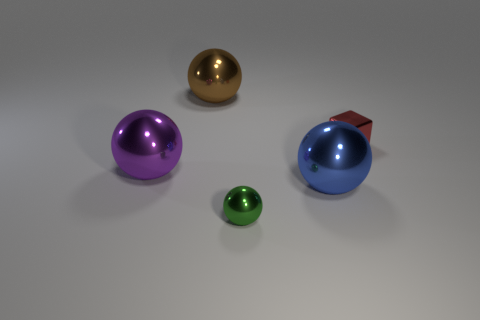Is the number of large purple balls that are right of the big purple object less than the number of green blocks?
Provide a short and direct response. No. Are there any red things that have the same material as the big purple ball?
Your answer should be compact. Yes. There is a red object; is its size the same as the brown object behind the large blue object?
Your response must be concise. No. Is there a metal sphere that has the same color as the tiny block?
Ensure brevity in your answer.  No. There is a big purple metallic object; how many objects are in front of it?
Give a very brief answer. 2. What is the object that is in front of the tiny metal cube and behind the big blue shiny sphere made of?
Offer a very short reply. Metal. How many other objects are the same size as the red shiny object?
Offer a very short reply. 1. There is a metallic thing to the right of the large sphere to the right of the brown thing; what is its color?
Ensure brevity in your answer.  Red. Is there a metal ball?
Your response must be concise. Yes. Do the large purple metallic object and the blue thing have the same shape?
Your answer should be very brief. Yes. 